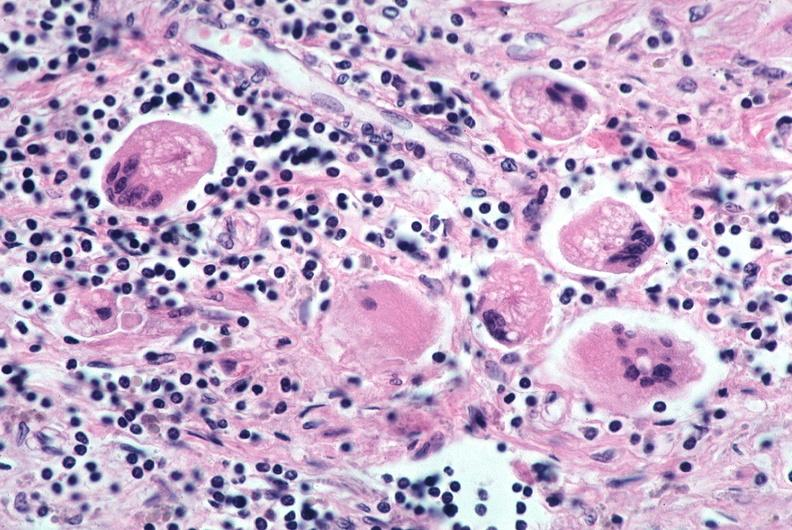how does this image show lung, sarcoidosis, multinucleated giant cells?
Answer the question using a single word or phrase. With asteroid bodies 